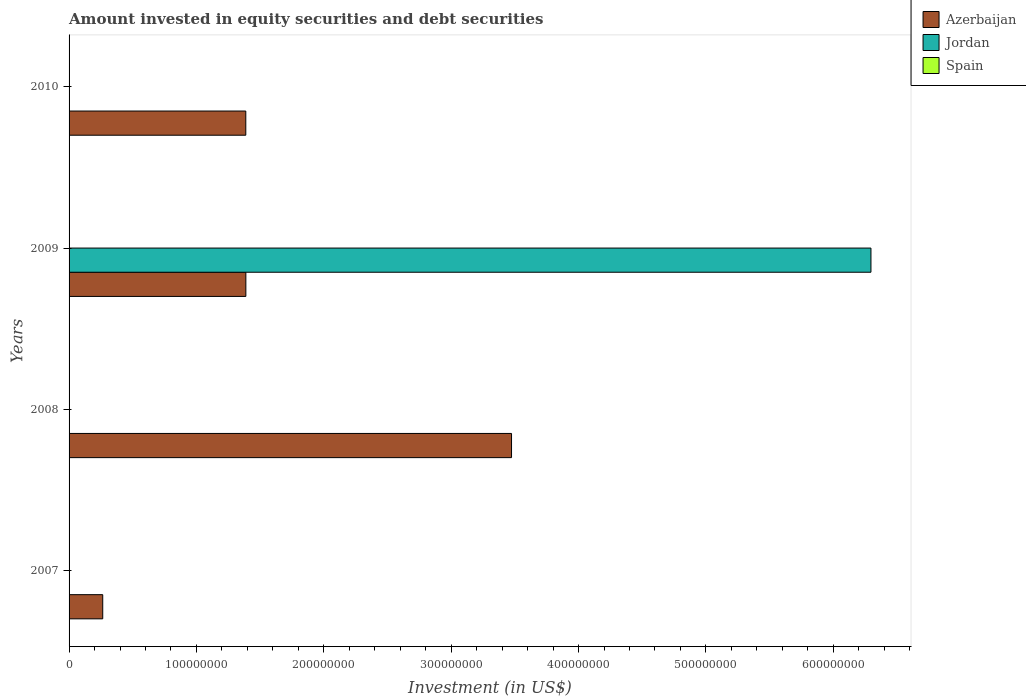How many different coloured bars are there?
Ensure brevity in your answer.  2. Are the number of bars on each tick of the Y-axis equal?
Ensure brevity in your answer.  No. How many bars are there on the 3rd tick from the top?
Your answer should be compact. 1. How many bars are there on the 2nd tick from the bottom?
Provide a short and direct response. 1. What is the label of the 1st group of bars from the top?
Give a very brief answer. 2010. What is the amount invested in equity securities and debt securities in Jordan in 2010?
Make the answer very short. 0. Across all years, what is the maximum amount invested in equity securities and debt securities in Azerbaijan?
Keep it short and to the point. 3.47e+08. Across all years, what is the minimum amount invested in equity securities and debt securities in Spain?
Provide a succinct answer. 0. What is the total amount invested in equity securities and debt securities in Azerbaijan in the graph?
Your answer should be very brief. 6.51e+08. What is the difference between the amount invested in equity securities and debt securities in Azerbaijan in 2008 and that in 2010?
Keep it short and to the point. 2.09e+08. What is the difference between the amount invested in equity securities and debt securities in Spain in 2010 and the amount invested in equity securities and debt securities in Azerbaijan in 2007?
Your response must be concise. -2.64e+07. What is the average amount invested in equity securities and debt securities in Jordan per year?
Provide a short and direct response. 1.57e+08. In the year 2009, what is the difference between the amount invested in equity securities and debt securities in Jordan and amount invested in equity securities and debt securities in Azerbaijan?
Keep it short and to the point. 4.91e+08. In how many years, is the amount invested in equity securities and debt securities in Azerbaijan greater than 560000000 US$?
Keep it short and to the point. 0. What is the ratio of the amount invested in equity securities and debt securities in Azerbaijan in 2009 to that in 2010?
Your response must be concise. 1. Is the amount invested in equity securities and debt securities in Azerbaijan in 2007 less than that in 2010?
Provide a succinct answer. Yes. What is the difference between the highest and the lowest amount invested in equity securities and debt securities in Jordan?
Offer a very short reply. 6.30e+08. What is the difference between two consecutive major ticks on the X-axis?
Offer a very short reply. 1.00e+08. Are the values on the major ticks of X-axis written in scientific E-notation?
Give a very brief answer. No. Does the graph contain any zero values?
Your answer should be compact. Yes. How many legend labels are there?
Offer a terse response. 3. What is the title of the graph?
Your answer should be very brief. Amount invested in equity securities and debt securities. Does "Portugal" appear as one of the legend labels in the graph?
Your answer should be compact. No. What is the label or title of the X-axis?
Offer a terse response. Investment (in US$). What is the label or title of the Y-axis?
Provide a short and direct response. Years. What is the Investment (in US$) of Azerbaijan in 2007?
Provide a succinct answer. 2.64e+07. What is the Investment (in US$) in Azerbaijan in 2008?
Provide a succinct answer. 3.47e+08. What is the Investment (in US$) in Spain in 2008?
Make the answer very short. 0. What is the Investment (in US$) of Azerbaijan in 2009?
Your answer should be very brief. 1.39e+08. What is the Investment (in US$) of Jordan in 2009?
Give a very brief answer. 6.30e+08. What is the Investment (in US$) of Azerbaijan in 2010?
Provide a succinct answer. 1.39e+08. What is the Investment (in US$) in Jordan in 2010?
Offer a very short reply. 0. What is the Investment (in US$) of Spain in 2010?
Your response must be concise. 0. Across all years, what is the maximum Investment (in US$) in Azerbaijan?
Your answer should be compact. 3.47e+08. Across all years, what is the maximum Investment (in US$) in Jordan?
Ensure brevity in your answer.  6.30e+08. Across all years, what is the minimum Investment (in US$) of Azerbaijan?
Make the answer very short. 2.64e+07. Across all years, what is the minimum Investment (in US$) of Jordan?
Your answer should be compact. 0. What is the total Investment (in US$) of Azerbaijan in the graph?
Give a very brief answer. 6.51e+08. What is the total Investment (in US$) in Jordan in the graph?
Your answer should be compact. 6.30e+08. What is the total Investment (in US$) in Spain in the graph?
Your response must be concise. 0. What is the difference between the Investment (in US$) in Azerbaijan in 2007 and that in 2008?
Your response must be concise. -3.21e+08. What is the difference between the Investment (in US$) in Azerbaijan in 2007 and that in 2009?
Give a very brief answer. -1.12e+08. What is the difference between the Investment (in US$) of Azerbaijan in 2007 and that in 2010?
Offer a very short reply. -1.12e+08. What is the difference between the Investment (in US$) in Azerbaijan in 2008 and that in 2009?
Ensure brevity in your answer.  2.09e+08. What is the difference between the Investment (in US$) in Azerbaijan in 2008 and that in 2010?
Ensure brevity in your answer.  2.09e+08. What is the difference between the Investment (in US$) in Azerbaijan in 2009 and that in 2010?
Your response must be concise. 4.40e+04. What is the difference between the Investment (in US$) of Azerbaijan in 2007 and the Investment (in US$) of Jordan in 2009?
Your answer should be compact. -6.03e+08. What is the difference between the Investment (in US$) in Azerbaijan in 2008 and the Investment (in US$) in Jordan in 2009?
Give a very brief answer. -2.82e+08. What is the average Investment (in US$) of Azerbaijan per year?
Your answer should be compact. 1.63e+08. What is the average Investment (in US$) in Jordan per year?
Keep it short and to the point. 1.57e+08. What is the average Investment (in US$) of Spain per year?
Give a very brief answer. 0. In the year 2009, what is the difference between the Investment (in US$) in Azerbaijan and Investment (in US$) in Jordan?
Keep it short and to the point. -4.91e+08. What is the ratio of the Investment (in US$) of Azerbaijan in 2007 to that in 2008?
Provide a succinct answer. 0.08. What is the ratio of the Investment (in US$) of Azerbaijan in 2007 to that in 2009?
Your answer should be compact. 0.19. What is the ratio of the Investment (in US$) of Azerbaijan in 2007 to that in 2010?
Your answer should be compact. 0.19. What is the ratio of the Investment (in US$) in Azerbaijan in 2008 to that in 2009?
Provide a succinct answer. 2.5. What is the ratio of the Investment (in US$) in Azerbaijan in 2008 to that in 2010?
Give a very brief answer. 2.5. What is the ratio of the Investment (in US$) of Azerbaijan in 2009 to that in 2010?
Offer a very short reply. 1. What is the difference between the highest and the second highest Investment (in US$) of Azerbaijan?
Provide a short and direct response. 2.09e+08. What is the difference between the highest and the lowest Investment (in US$) in Azerbaijan?
Your response must be concise. 3.21e+08. What is the difference between the highest and the lowest Investment (in US$) of Jordan?
Ensure brevity in your answer.  6.30e+08. 